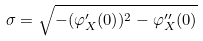<formula> <loc_0><loc_0><loc_500><loc_500>\sigma = \sqrt { - ( \varphi ^ { \prime } _ { X } ( 0 ) ) ^ { 2 } - \varphi ^ { \prime \prime } _ { X } ( 0 ) }</formula> 